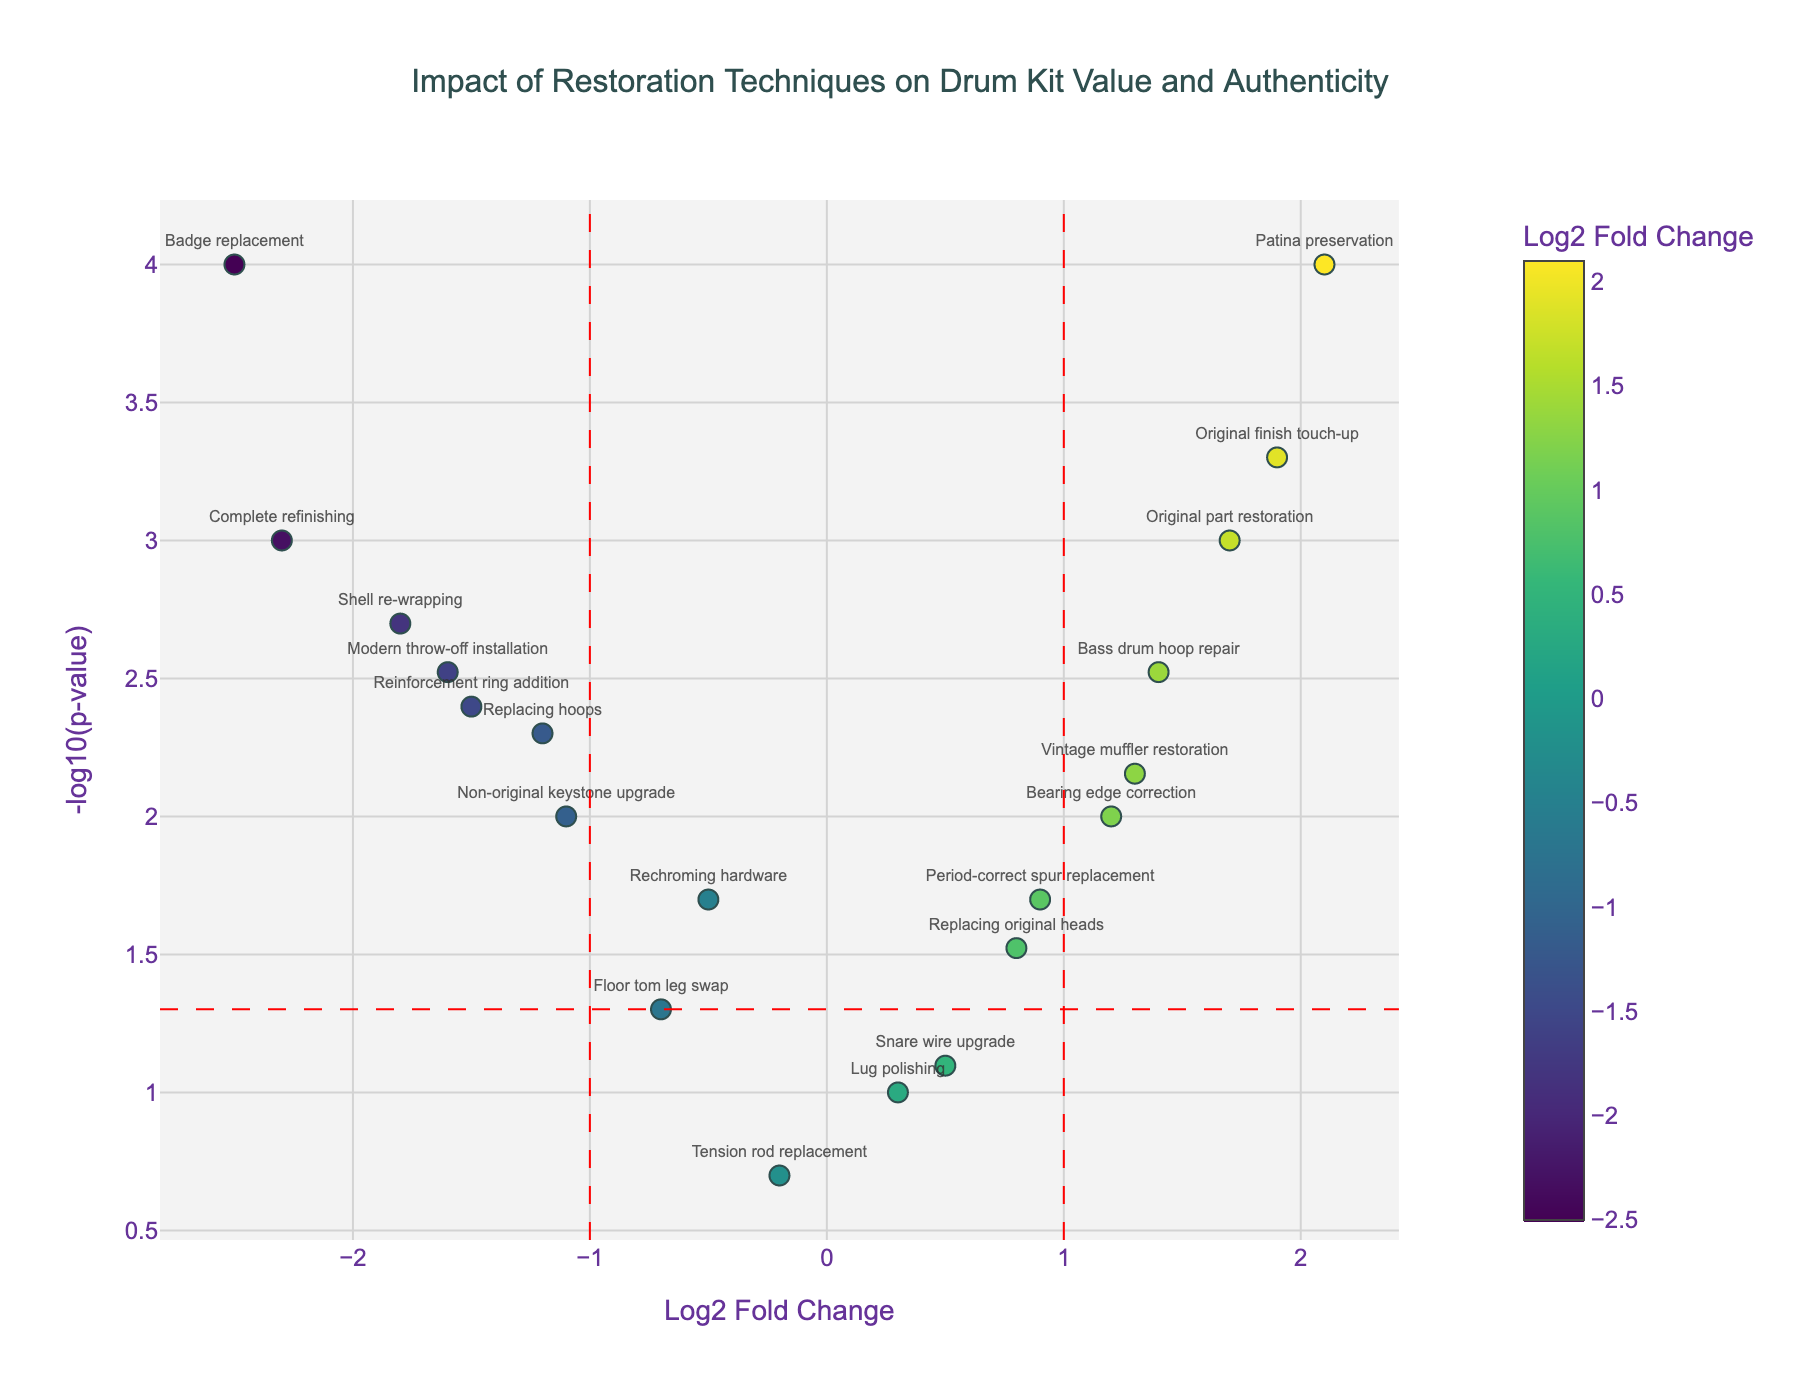What is the title of the plot? The title of the plot is located at the top center of the figure. It reads "Impact of Restoration Techniques on Drum Kit Value and Authenticity".
Answer: Impact of Restoration Techniques on Drum Kit Value and Authenticity What are the two axes representing in the figure? The x-axis represents the Log2 Fold Change (LogFC) of the restoration techniques, while the y-axis represents the -log10(p-value) of the techniques' impact.
Answer: Log2 Fold Change on x-axis, -log10(p-value) on y-axis Which technique has the highest -log10(p-value) among all shown? The technique "Badge replacement" shows the highest -log10(p-value) on the y-axis in the plot, indicating its p-value is the lowest among all techniques.
Answer: Badge replacement Which techniques are considered significant and have a negative impact on drum kit value? Techniques with a LogFC less than -1 and -log10(p-value) above the threshold line (approximated as 1.3 for p-value 0.05) are significant. These include "Complete refinishing," "Shell re-wrapping," "Badge replacement," and "Modern throw-off installation."
Answer: Complete refinishing, Shell re-wrapping, Badge replacement, Modern throw-off installation What are the effects of "Original finish touch-up" on the drum kit's value and authenticity? "Original finish touch-up" has a LogFC of approximately 1.9 and a very low p-value, making it both statistically significant and having a positive impact on drum kit value and authenticity.
Answer: Positive, significant Among the techniques with positive LogFC values, which one has the lowest -log10(p-value)? The technique with a positive LogFC and the lowest -log10(p-value) among these is "Replacing original heads."
Answer: Replacing original heads Is "Bearing edge correction" statistically significant, and what is its impact? "Bearing edge correction" is statistically significant as it appears above the horizontal significance threshold line, and it has a positive LogFC around 1.2, indicating a positive impact on drum kit value.
Answer: Yes, positive impact Compare the impact of "Rechroming hardware" and "Lug polishing." Which one is more significant? "Rechroming hardware" has a more significant impact compared to "Lug polishing" as its -log10(p-value) is higher, even though both have similarly low but positive LogFC values.
Answer: Rechroming hardware What visual feature indicates the statistical significance threshold? The horizontal red dashed line on the plot indicates the statistical significance threshold for the p-value (usually 0.05, here represented as -log10(0.05) on the y-axis).
Answer: Horizontal red dashed line Which technique shows a significant positive effect and also is among the highest in LogFC? "Patina preservation" shows a significant positive effect, with one of the highest LogFC values and a very low p-value, making it highly significant.
Answer: Patina preservation 